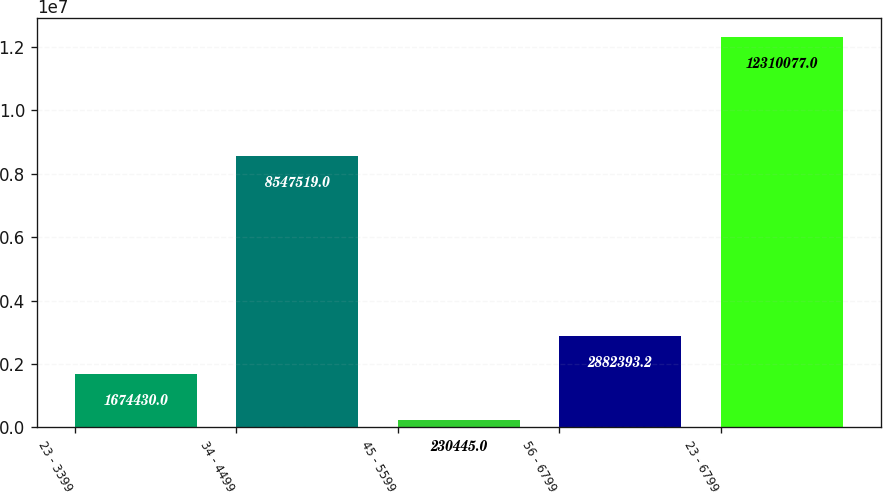Convert chart to OTSL. <chart><loc_0><loc_0><loc_500><loc_500><bar_chart><fcel>23 - 3399<fcel>34 - 4499<fcel>45 - 5599<fcel>56 - 6799<fcel>23 - 6799<nl><fcel>1.67443e+06<fcel>8.54752e+06<fcel>230445<fcel>2.88239e+06<fcel>1.23101e+07<nl></chart> 